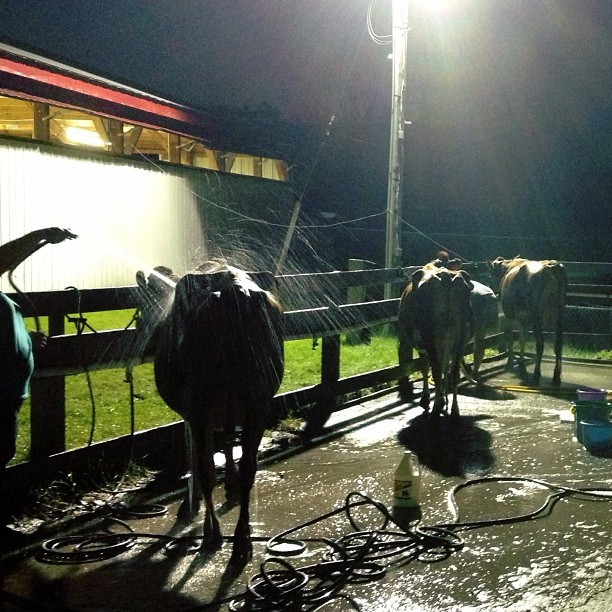Describe the objects in this image and their specific colors. I can see cow in black, gray, ivory, and darkgray tones, cow in black, ivory, and gray tones, cow in black, darkgreen, gray, and teal tones, and cow in black, turquoise, and teal tones in this image. 